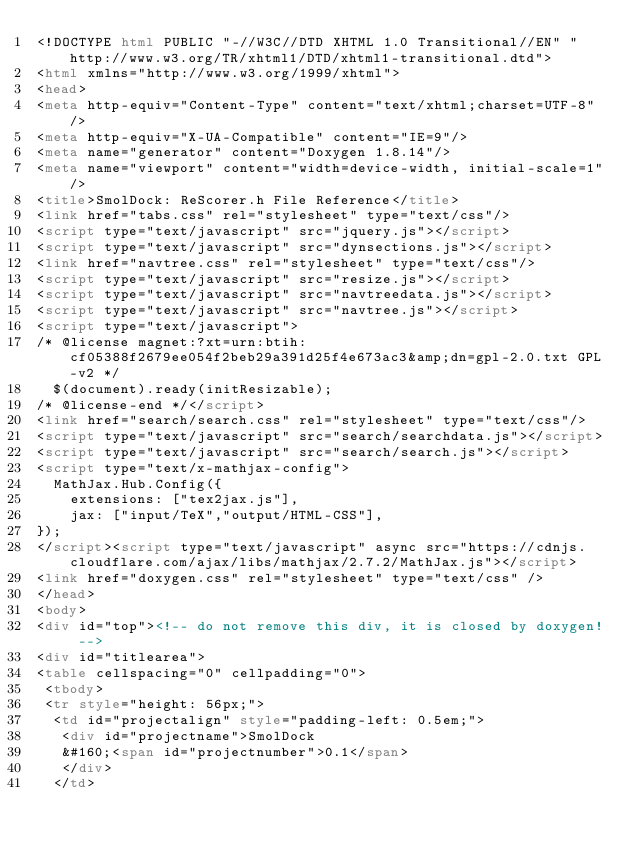<code> <loc_0><loc_0><loc_500><loc_500><_HTML_><!DOCTYPE html PUBLIC "-//W3C//DTD XHTML 1.0 Transitional//EN" "http://www.w3.org/TR/xhtml1/DTD/xhtml1-transitional.dtd">
<html xmlns="http://www.w3.org/1999/xhtml">
<head>
<meta http-equiv="Content-Type" content="text/xhtml;charset=UTF-8"/>
<meta http-equiv="X-UA-Compatible" content="IE=9"/>
<meta name="generator" content="Doxygen 1.8.14"/>
<meta name="viewport" content="width=device-width, initial-scale=1"/>
<title>SmolDock: ReScorer.h File Reference</title>
<link href="tabs.css" rel="stylesheet" type="text/css"/>
<script type="text/javascript" src="jquery.js"></script>
<script type="text/javascript" src="dynsections.js"></script>
<link href="navtree.css" rel="stylesheet" type="text/css"/>
<script type="text/javascript" src="resize.js"></script>
<script type="text/javascript" src="navtreedata.js"></script>
<script type="text/javascript" src="navtree.js"></script>
<script type="text/javascript">
/* @license magnet:?xt=urn:btih:cf05388f2679ee054f2beb29a391d25f4e673ac3&amp;dn=gpl-2.0.txt GPL-v2 */
  $(document).ready(initResizable);
/* @license-end */</script>
<link href="search/search.css" rel="stylesheet" type="text/css"/>
<script type="text/javascript" src="search/searchdata.js"></script>
<script type="text/javascript" src="search/search.js"></script>
<script type="text/x-mathjax-config">
  MathJax.Hub.Config({
    extensions: ["tex2jax.js"],
    jax: ["input/TeX","output/HTML-CSS"],
});
</script><script type="text/javascript" async src="https://cdnjs.cloudflare.com/ajax/libs/mathjax/2.7.2/MathJax.js"></script>
<link href="doxygen.css" rel="stylesheet" type="text/css" />
</head>
<body>
<div id="top"><!-- do not remove this div, it is closed by doxygen! -->
<div id="titlearea">
<table cellspacing="0" cellpadding="0">
 <tbody>
 <tr style="height: 56px;">
  <td id="projectalign" style="padding-left: 0.5em;">
   <div id="projectname">SmolDock
   &#160;<span id="projectnumber">0.1</span>
   </div>
  </td></code> 